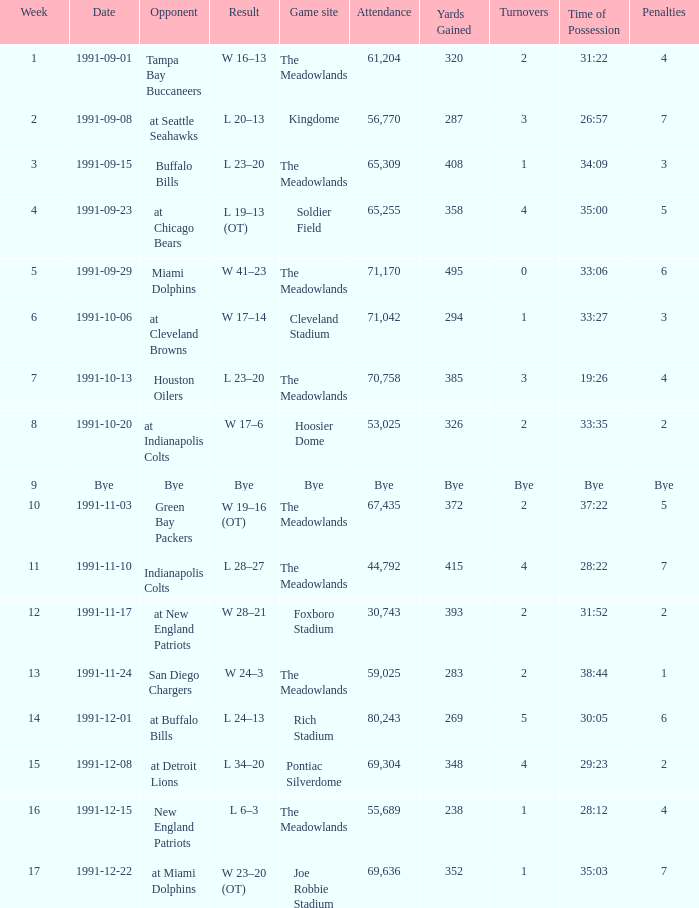Help me parse the entirety of this table. {'header': ['Week', 'Date', 'Opponent', 'Result', 'Game site', 'Attendance', 'Yards Gained', 'Turnovers', 'Time of Possession', 'Penalties'], 'rows': [['1', '1991-09-01', 'Tampa Bay Buccaneers', 'W 16–13', 'The Meadowlands', '61,204', '320', '2', '31:22', '4'], ['2', '1991-09-08', 'at Seattle Seahawks', 'L 20–13', 'Kingdome', '56,770', '287', '3', '26:57', '7'], ['3', '1991-09-15', 'Buffalo Bills', 'L 23–20', 'The Meadowlands', '65,309', '408', '1', '34:09', '3'], ['4', '1991-09-23', 'at Chicago Bears', 'L 19–13 (OT)', 'Soldier Field', '65,255', '358', '4', '35:00', '5'], ['5', '1991-09-29', 'Miami Dolphins', 'W 41–23', 'The Meadowlands', '71,170', '495', '0', '33:06', '6'], ['6', '1991-10-06', 'at Cleveland Browns', 'W 17–14', 'Cleveland Stadium', '71,042', '294', '1', '33:27', '3'], ['7', '1991-10-13', 'Houston Oilers', 'L 23–20', 'The Meadowlands', '70,758', '385', '3', '19:26', '4'], ['8', '1991-10-20', 'at Indianapolis Colts', 'W 17–6', 'Hoosier Dome', '53,025', '326', '2', '33:35', '2'], ['9', 'Bye', 'Bye', 'Bye', 'Bye', 'Bye', 'Bye', 'Bye', 'Bye', 'Bye'], ['10', '1991-11-03', 'Green Bay Packers', 'W 19–16 (OT)', 'The Meadowlands', '67,435', '372', '2', '37:22', '5'], ['11', '1991-11-10', 'Indianapolis Colts', 'L 28–27', 'The Meadowlands', '44,792', '415', '4', '28:22', '7'], ['12', '1991-11-17', 'at New England Patriots', 'W 28–21', 'Foxboro Stadium', '30,743', '393', '2', '31:52', '2'], ['13', '1991-11-24', 'San Diego Chargers', 'W 24–3', 'The Meadowlands', '59,025', '283', '2', '38:44', '1'], ['14', '1991-12-01', 'at Buffalo Bills', 'L 24–13', 'Rich Stadium', '80,243', '269', '5', '30:05', '6'], ['15', '1991-12-08', 'at Detroit Lions', 'L 34–20', 'Pontiac Silverdome', '69,304', '348', '4', '29:23', '2'], ['16', '1991-12-15', 'New England Patriots', 'L 6–3', 'The Meadowlands', '55,689', '238', '1', '28:12', '4'], ['17', '1991-12-22', 'at Miami Dolphins', 'W 23–20 (OT)', 'Joe Robbie Stadium', '69,636', '352', '1', '35:03', '7']]} What was the Attendance of the Game at Hoosier Dome? 53025.0. 